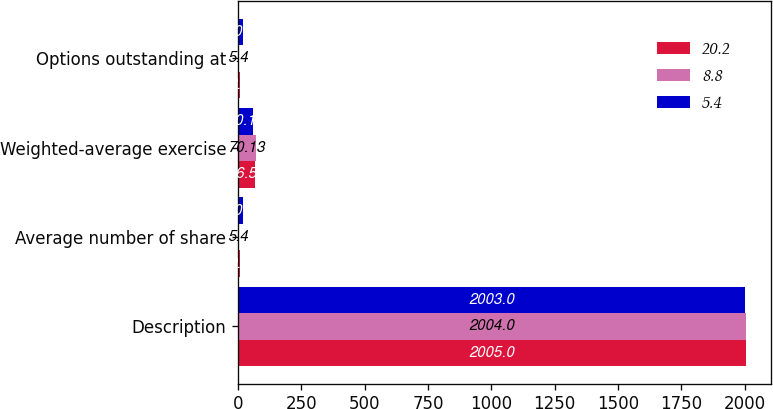<chart> <loc_0><loc_0><loc_500><loc_500><stacked_bar_chart><ecel><fcel>Description<fcel>Average number of share<fcel>Weighted-average exercise<fcel>Options outstanding at<nl><fcel>20.2<fcel>2005<fcel>9.1<fcel>66.58<fcel>8.8<nl><fcel>8.8<fcel>2004<fcel>5.4<fcel>70.13<fcel>5.4<nl><fcel>5.4<fcel>2003<fcel>20.5<fcel>60.19<fcel>20.2<nl></chart> 